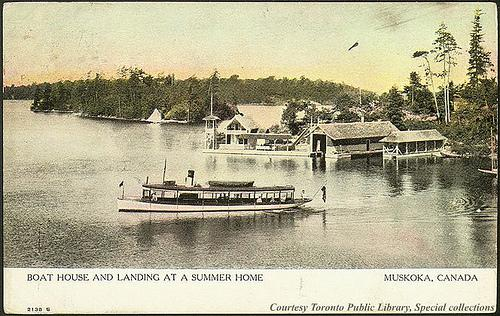Question: what country was this taken in?
Choices:
A. United States.
B. United Kingdom.
C. Mexico.
D. Canada.
Answer with the letter. Answer: D Question: when was this photo taken?
Choices:
A. At night.
B. In the morning.
C. During the daytime.
D. At dawn.
Answer with the letter. Answer: C Question: where did this picture come from?
Choices:
A. My mom.
B. The internet.
C. A book.
D. Toronto Public Library.
Answer with the letter. Answer: D Question: who would drive this vehicle?
Choices:
A. The driver.
B. My father.
C. A captain.
D. The best driver.
Answer with the letter. Answer: C 